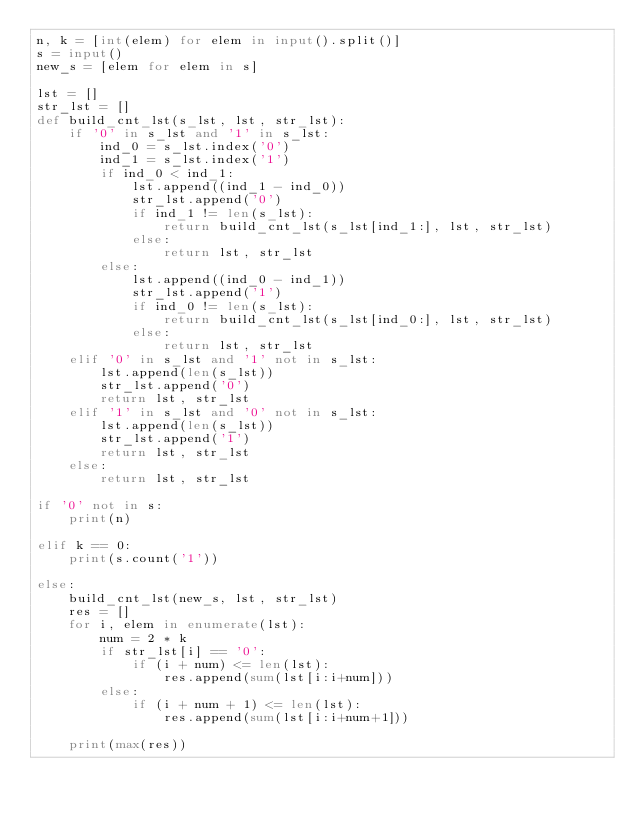Convert code to text. <code><loc_0><loc_0><loc_500><loc_500><_Python_>n, k = [int(elem) for elem in input().split()]
s = input()
new_s = [elem for elem in s]

lst = []
str_lst = []
def build_cnt_lst(s_lst, lst, str_lst):
    if '0' in s_lst and '1' in s_lst:    
        ind_0 = s_lst.index('0')
        ind_1 = s_lst.index('1')
        if ind_0 < ind_1:
            lst.append((ind_1 - ind_0))
            str_lst.append('0')
            if ind_1 != len(s_lst):
                return build_cnt_lst(s_lst[ind_1:], lst, str_lst)
            else:
                return lst, str_lst
        else:
            lst.append((ind_0 - ind_1))
            str_lst.append('1')
            if ind_0 != len(s_lst):
                return build_cnt_lst(s_lst[ind_0:], lst, str_lst)
            else:
                return lst, str_lst
    elif '0' in s_lst and '1' not in s_lst:
        lst.append(len(s_lst))
        str_lst.append('0')
        return lst, str_lst
    elif '1' in s_lst and '0' not in s_lst:
        lst.append(len(s_lst))
        str_lst.append('1')
        return lst, str_lst
    else:
        return lst, str_lst

if '0' not in s:
    print(n)

elif k == 0:
    print(s.count('1'))
    
else:
    build_cnt_lst(new_s, lst, str_lst)
    res = []
    for i, elem in enumerate(lst):
        num = 2 * k
        if str_lst[i] == '0':
            if (i + num) <= len(lst):
                res.append(sum(lst[i:i+num]))
        else:
            if (i + num + 1) <= len(lst):
                res.append(sum(lst[i:i+num+1]))

    print(max(res))
</code> 